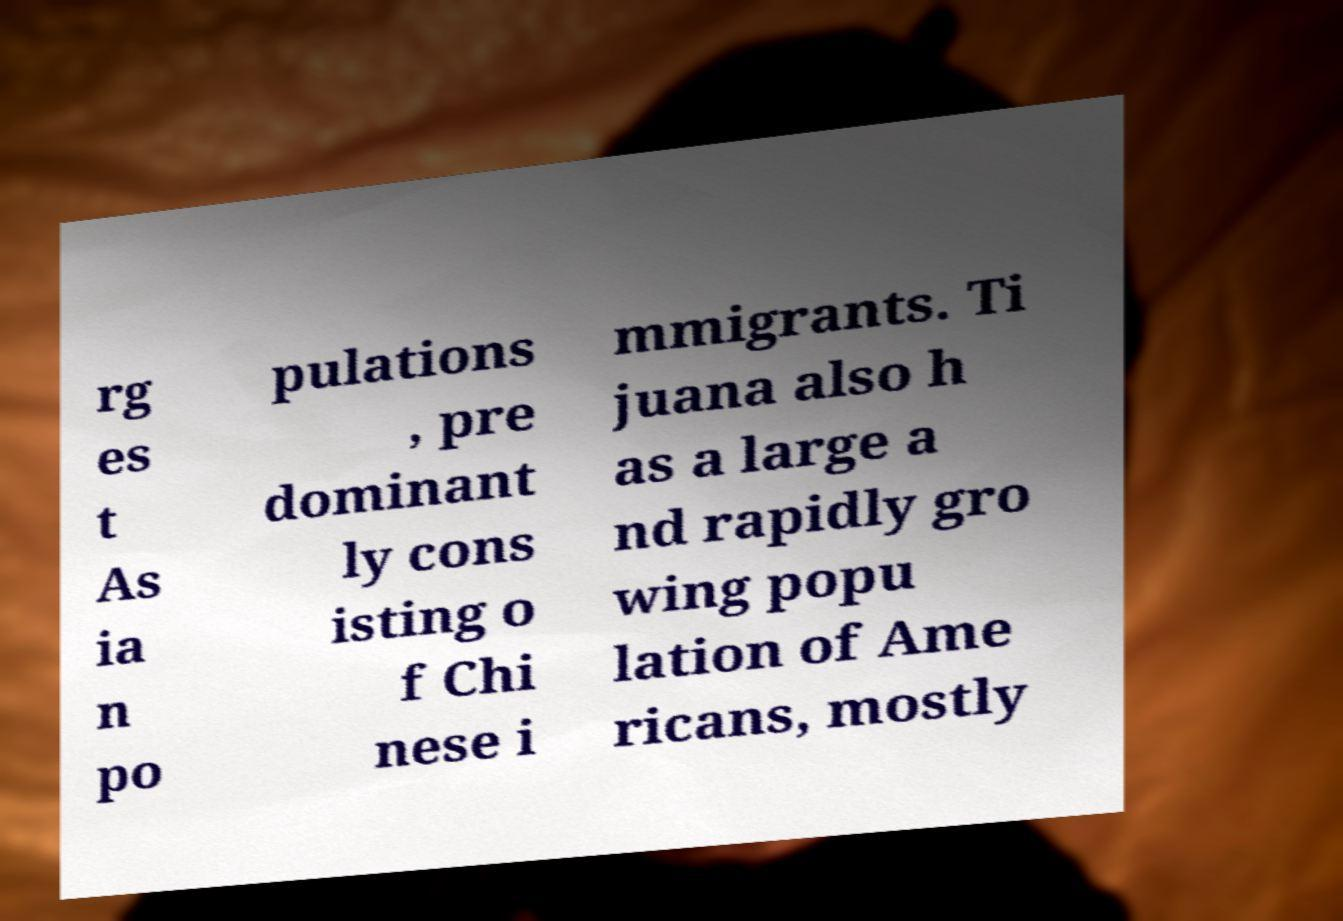Can you accurately transcribe the text from the provided image for me? rg es t As ia n po pulations , pre dominant ly cons isting o f Chi nese i mmigrants. Ti juana also h as a large a nd rapidly gro wing popu lation of Ame ricans, mostly 